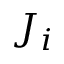<formula> <loc_0><loc_0><loc_500><loc_500>J _ { i }</formula> 